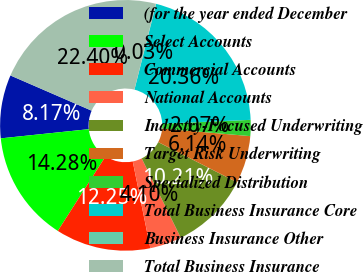Convert chart to OTSL. <chart><loc_0><loc_0><loc_500><loc_500><pie_chart><fcel>(for the year ended December<fcel>Select Accounts<fcel>Commercial Accounts<fcel>National Accounts<fcel>Industry-Focused Underwriting<fcel>Target Risk Underwriting<fcel>Specialized Distribution<fcel>Total Business Insurance Core<fcel>Business Insurance Other<fcel>Total Business Insurance<nl><fcel>8.17%<fcel>14.28%<fcel>12.25%<fcel>4.1%<fcel>10.21%<fcel>6.14%<fcel>2.07%<fcel>20.36%<fcel>0.03%<fcel>22.4%<nl></chart> 